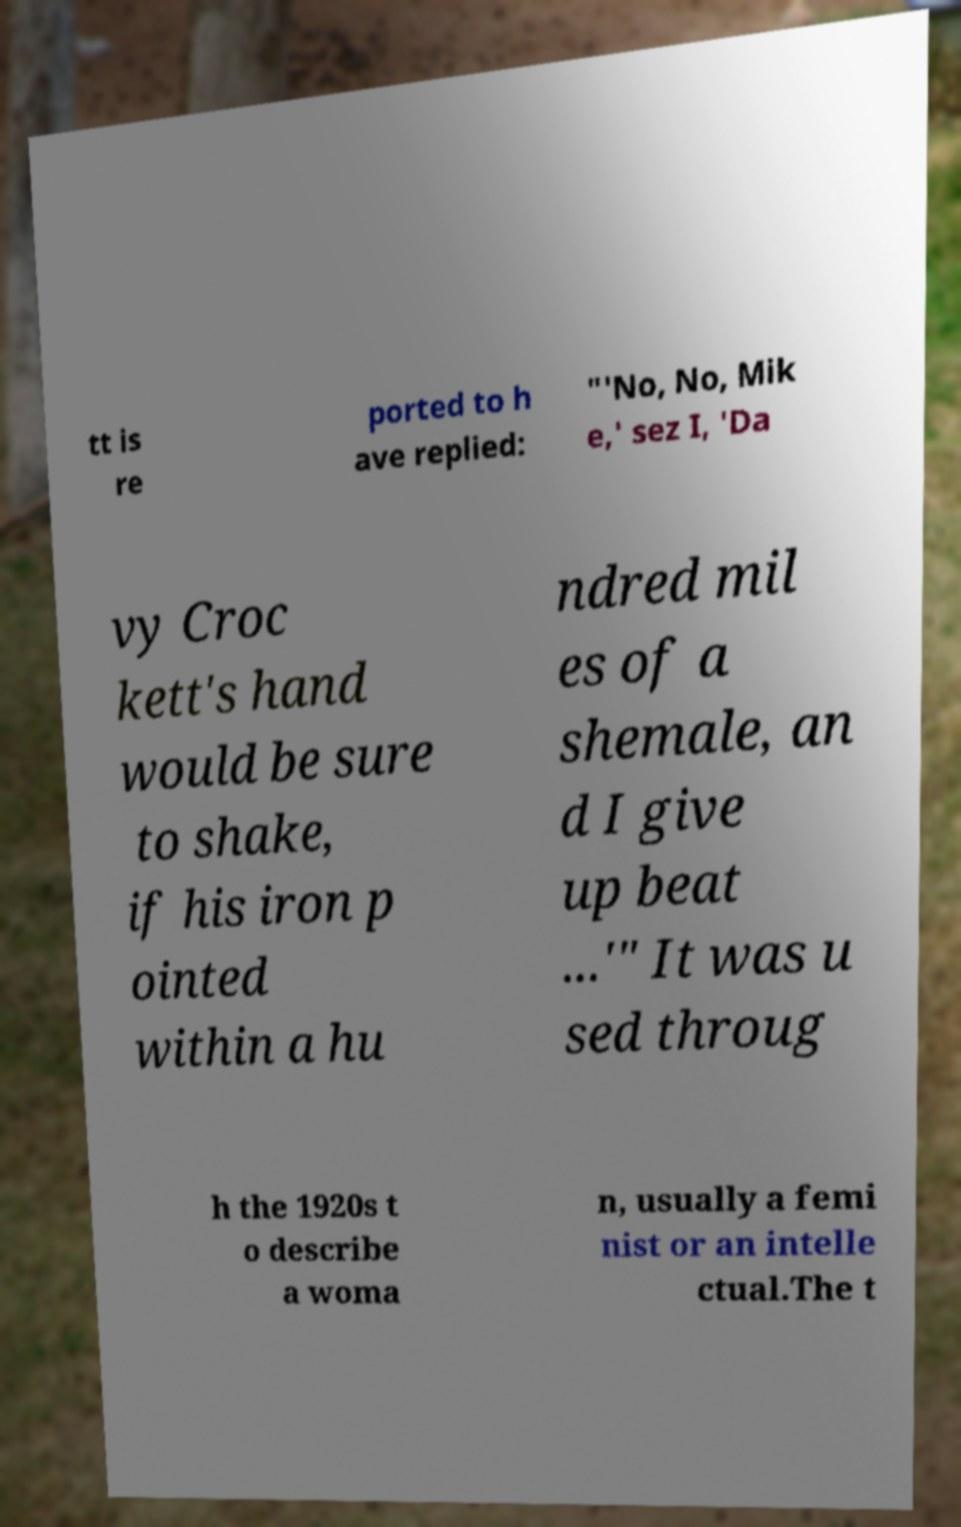Could you extract and type out the text from this image? tt is re ported to h ave replied: "'No, No, Mik e,' sez I, 'Da vy Croc kett's hand would be sure to shake, if his iron p ointed within a hu ndred mil es of a shemale, an d I give up beat ...'" It was u sed throug h the 1920s t o describe a woma n, usually a femi nist or an intelle ctual.The t 